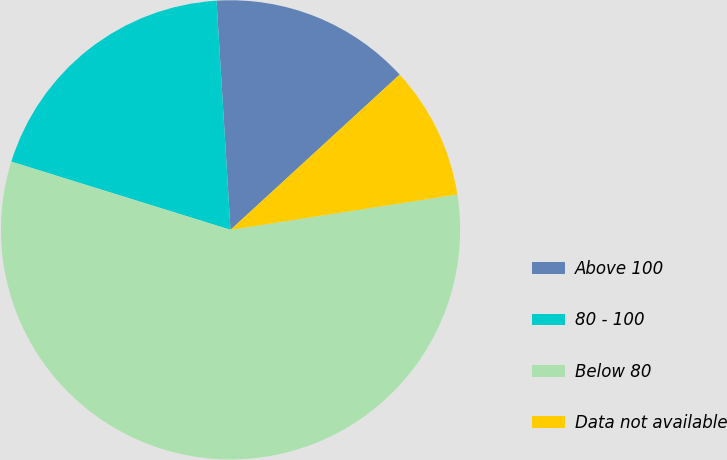<chart> <loc_0><loc_0><loc_500><loc_500><pie_chart><fcel>Above 100<fcel>80 - 100<fcel>Below 80<fcel>Data not available<nl><fcel>14.15%<fcel>19.23%<fcel>57.25%<fcel>9.36%<nl></chart> 